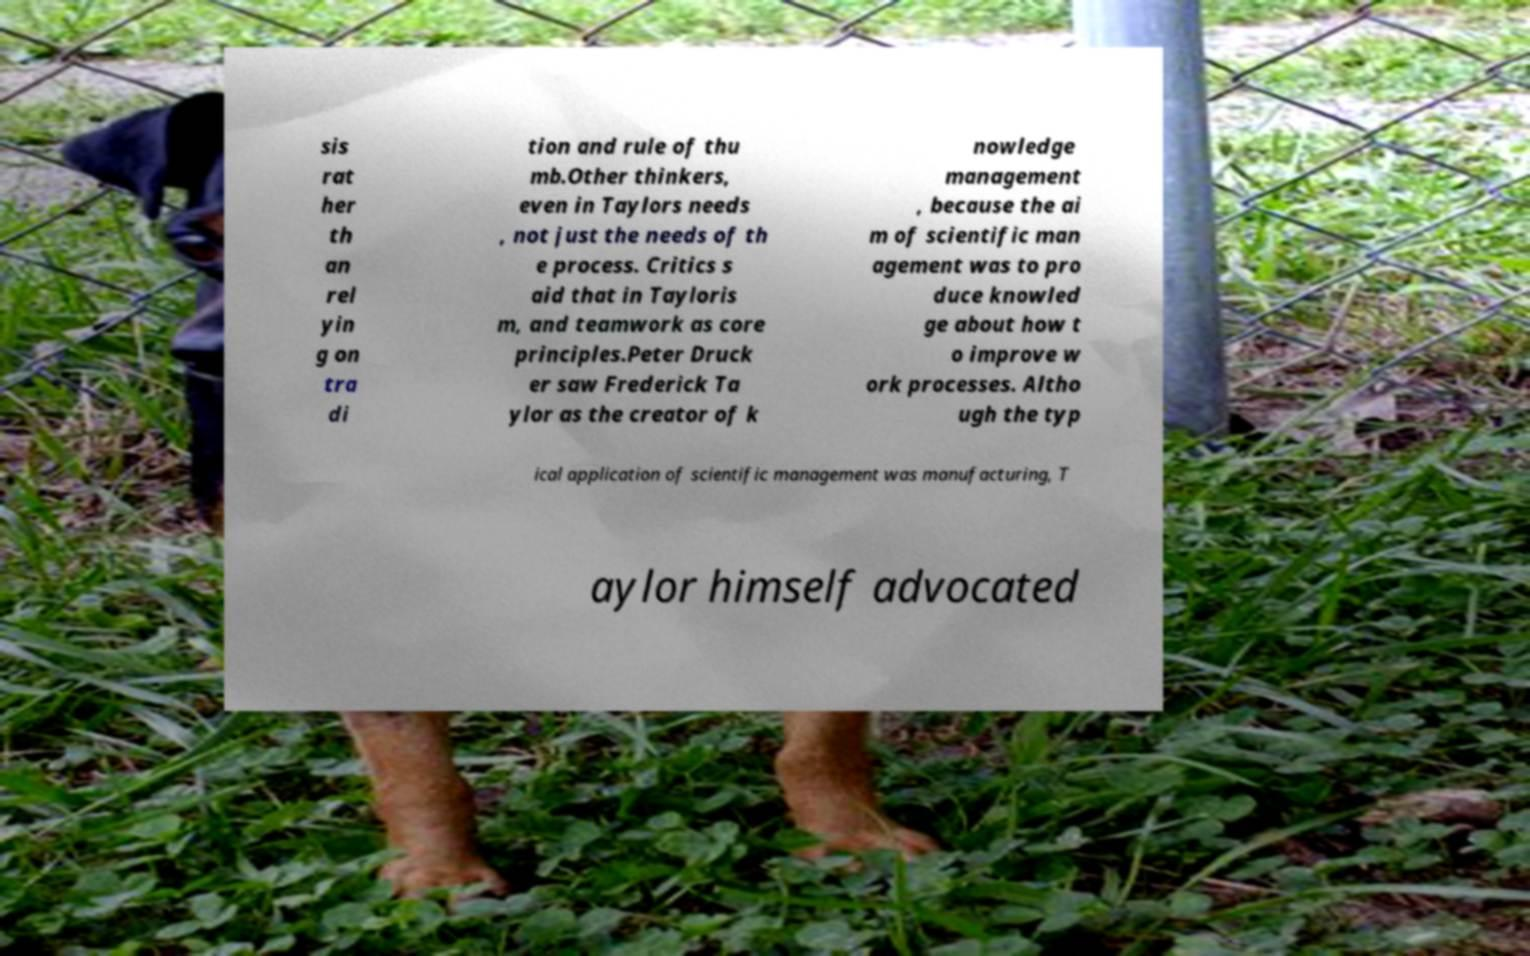Please identify and transcribe the text found in this image. sis rat her th an rel yin g on tra di tion and rule of thu mb.Other thinkers, even in Taylors needs , not just the needs of th e process. Critics s aid that in Tayloris m, and teamwork as core principles.Peter Druck er saw Frederick Ta ylor as the creator of k nowledge management , because the ai m of scientific man agement was to pro duce knowled ge about how t o improve w ork processes. Altho ugh the typ ical application of scientific management was manufacturing, T aylor himself advocated 